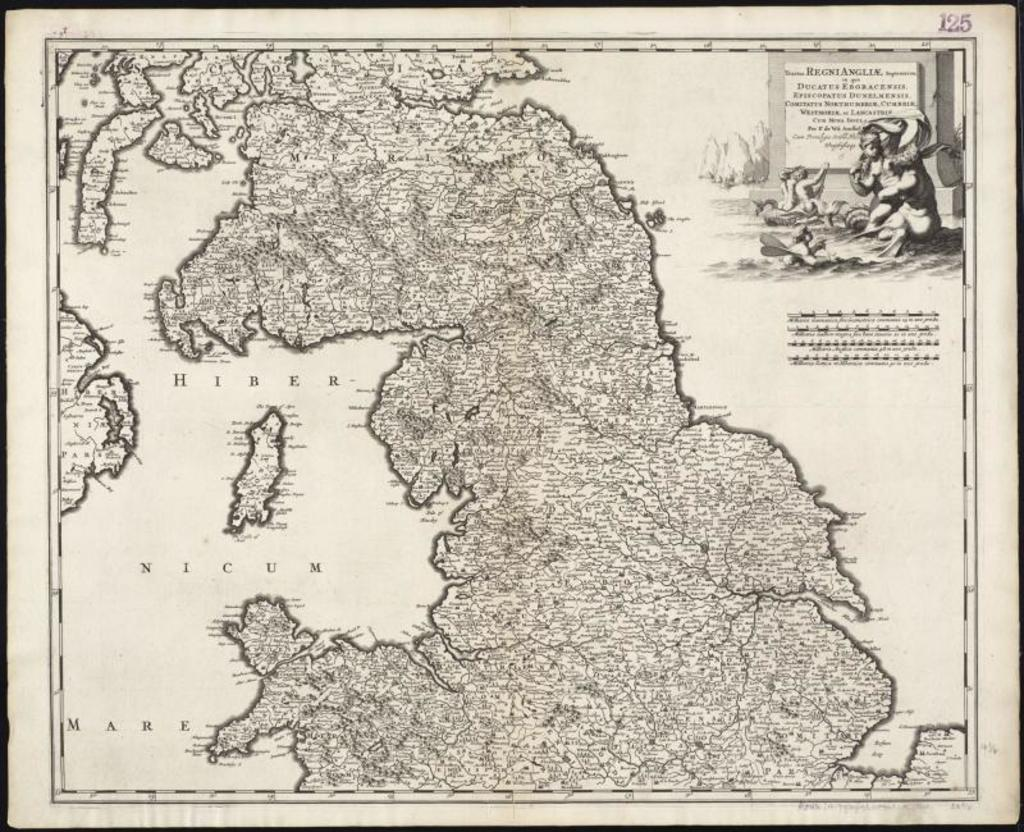What is the main subject of the poster in the image? The poster contains a map. Are there any other elements on the poster besides the map? Yes, there are pictures and writing on the poster. How does the poster handle the sleet in the image? There is no mention of sleet in the image or on the poster; the poster contains a map, pictures, and writing. 